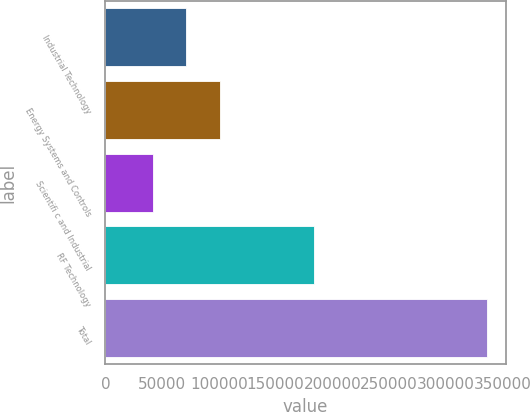<chart> <loc_0><loc_0><loc_500><loc_500><bar_chart><fcel>Industrial Technology<fcel>Energy Systems and Controls<fcel>Scientifi c and Industrial<fcel>RF Technology<fcel>Total<nl><fcel>71373.3<fcel>100773<fcel>41974<fcel>183742<fcel>335967<nl></chart> 